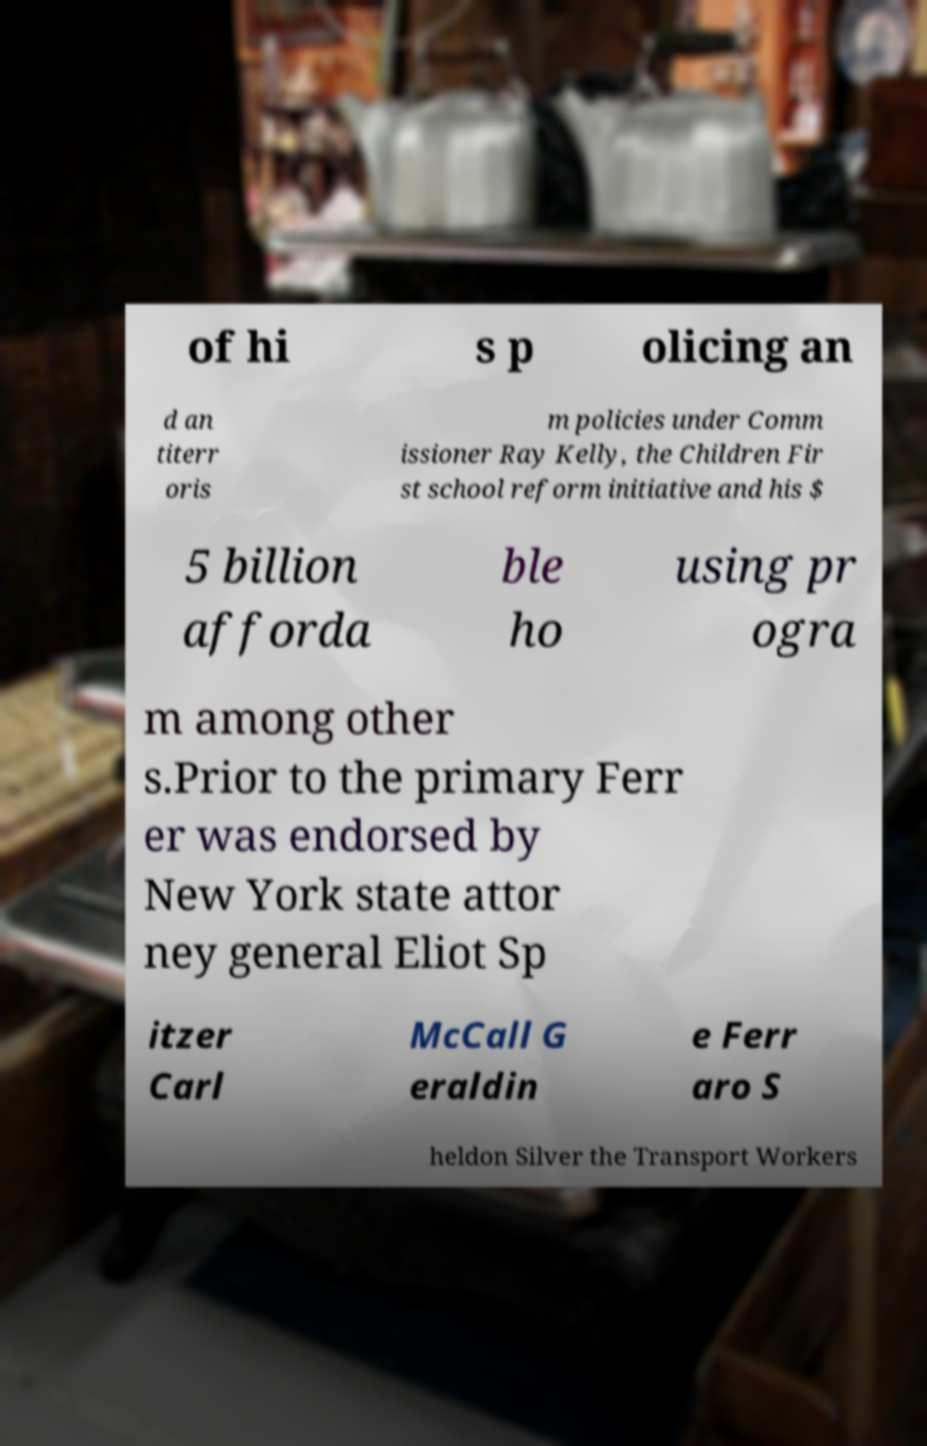Please identify and transcribe the text found in this image. of hi s p olicing an d an titerr oris m policies under Comm issioner Ray Kelly, the Children Fir st school reform initiative and his $ 5 billion afforda ble ho using pr ogra m among other s.Prior to the primary Ferr er was endorsed by New York state attor ney general Eliot Sp itzer Carl McCall G eraldin e Ferr aro S heldon Silver the Transport Workers 